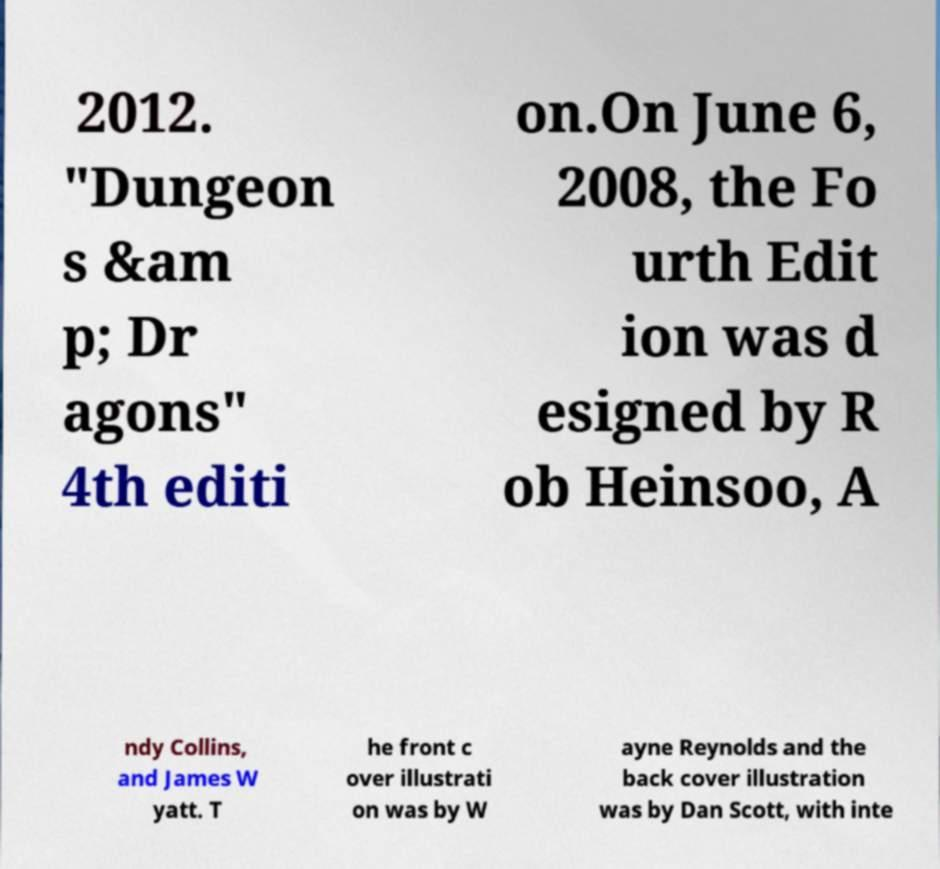Can you read and provide the text displayed in the image?This photo seems to have some interesting text. Can you extract and type it out for me? 2012. "Dungeon s &am p; Dr agons" 4th editi on.On June 6, 2008, the Fo urth Edit ion was d esigned by R ob Heinsoo, A ndy Collins, and James W yatt. T he front c over illustrati on was by W ayne Reynolds and the back cover illustration was by Dan Scott, with inte 